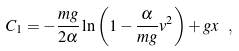Convert formula to latex. <formula><loc_0><loc_0><loc_500><loc_500>C _ { 1 } = - \frac { m g } { 2 \alpha } \ln \left ( 1 - \frac { \alpha } { m g } v ^ { 2 } \right ) + g x \ ,</formula> 